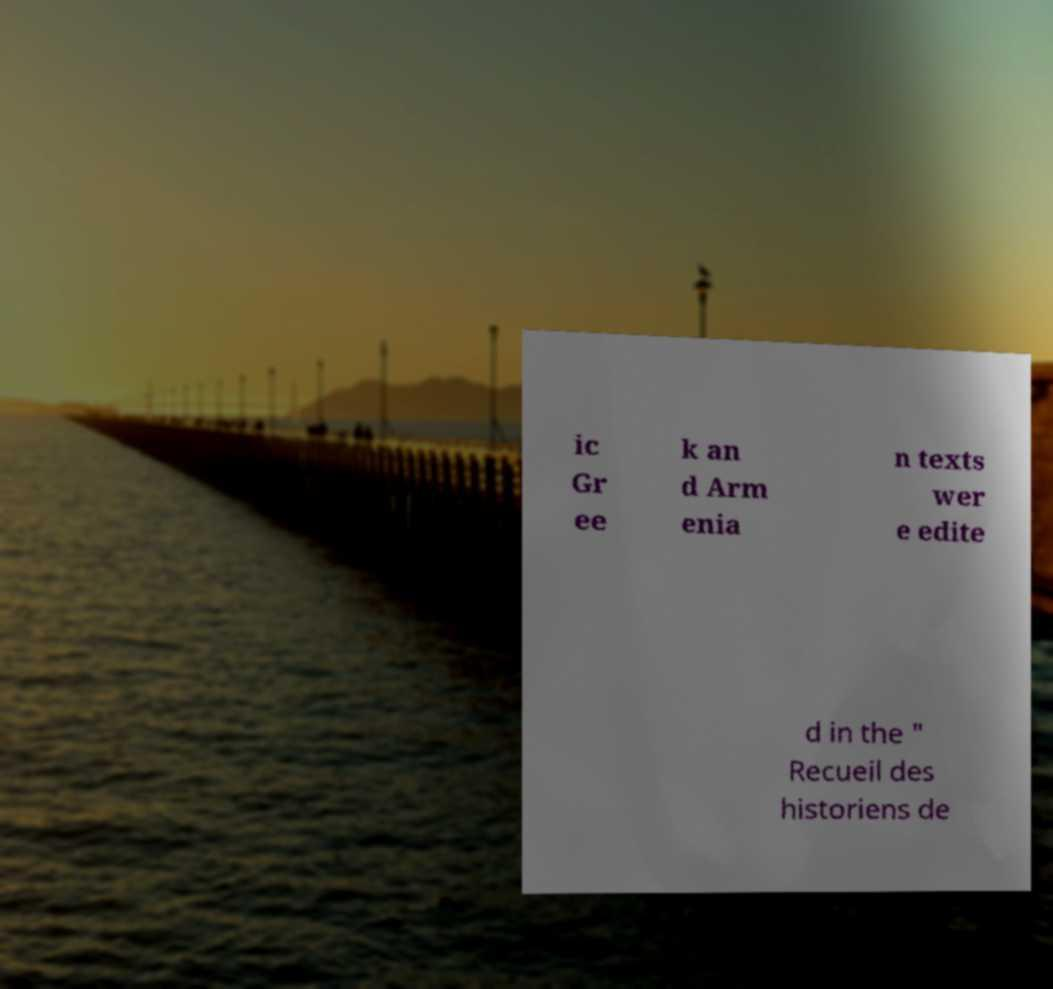Can you read and provide the text displayed in the image?This photo seems to have some interesting text. Can you extract and type it out for me? ic Gr ee k an d Arm enia n texts wer e edite d in the " Recueil des historiens de 